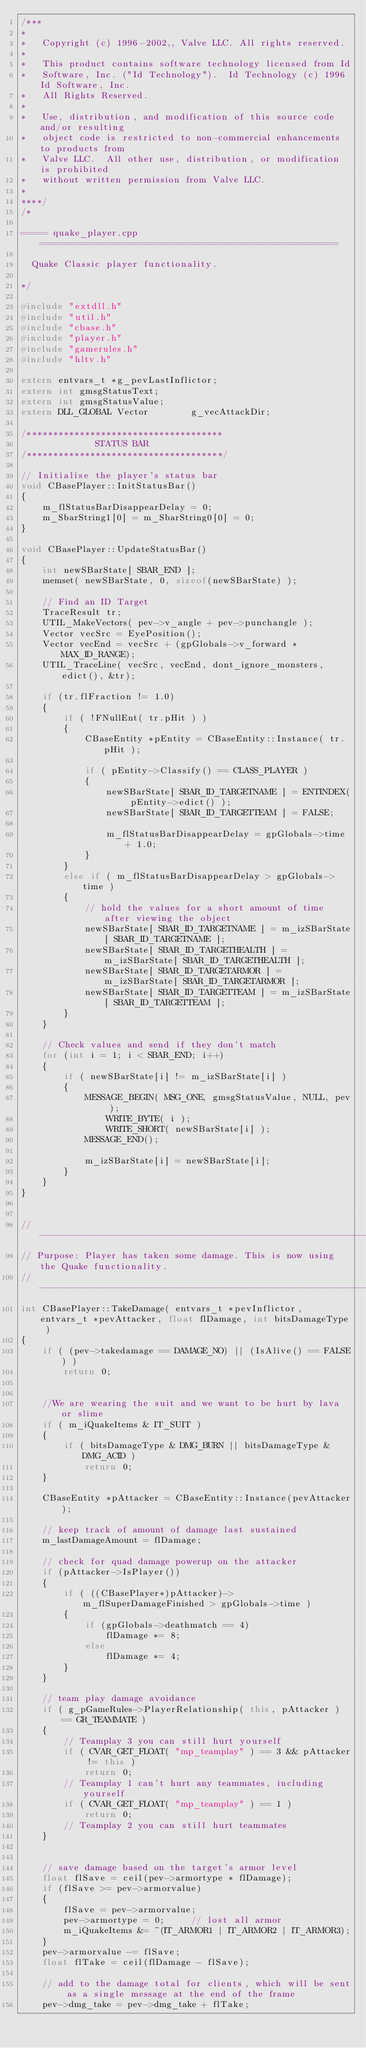Convert code to text. <code><loc_0><loc_0><loc_500><loc_500><_C++_>/***
*
*	Copyright (c) 1996-2002,, Valve LLC. All rights reserved.
*	
*	This product contains software technology licensed from Id 
*	Software, Inc. ("Id Technology").  Id Technology (c) 1996 Id Software, Inc. 
*	All Rights Reserved.
*
*   Use, distribution, and modification of this source code and/or resulting
*   object code is restricted to non-commercial enhancements to products from
*   Valve LLC.  All other use, distribution, or modification is prohibited
*   without written permission from Valve LLC.
*
****/
/*

===== quake_player.cpp ========================================================

  Quake Classic player functionality.

*/

#include "extdll.h"
#include "util.h"
#include "cbase.h"
#include "player.h"
#include "gamerules.h"
#include "hltv.h"

extern entvars_t *g_pevLastInflictor;
extern int gmsgStatusText;
extern int gmsgStatusValue; 
extern DLL_GLOBAL Vector		g_vecAttackDir;

/*************************************
			  STATUS BAR 
/*************************************/

// Initialise the player's status bar
void CBasePlayer::InitStatusBar()
{
	m_flStatusBarDisappearDelay = 0;
	m_SbarString1[0] = m_SbarString0[0] = 0; 
}

void CBasePlayer::UpdateStatusBar()
{
	int newSBarState[ SBAR_END ];
	memset( newSBarState, 0, sizeof(newSBarState) );

	// Find an ID Target
	TraceResult tr;
	UTIL_MakeVectors( pev->v_angle + pev->punchangle );
	Vector vecSrc = EyePosition();
	Vector vecEnd = vecSrc + (gpGlobals->v_forward * MAX_ID_RANGE);
	UTIL_TraceLine( vecSrc, vecEnd, dont_ignore_monsters, edict(), &tr);

	if (tr.flFraction != 1.0)
	{
		if ( !FNullEnt( tr.pHit ) )
		{
			CBaseEntity *pEntity = CBaseEntity::Instance( tr.pHit );

			if ( pEntity->Classify() == CLASS_PLAYER )
			{
				newSBarState[ SBAR_ID_TARGETNAME ] = ENTINDEX( pEntity->edict() );
				newSBarState[ SBAR_ID_TARGETTEAM ] = FALSE;
					
				m_flStatusBarDisappearDelay = gpGlobals->time + 1.0;
			}
		}
		else if ( m_flStatusBarDisappearDelay > gpGlobals->time )
		{
			// hold the values for a short amount of time after viewing the object
			newSBarState[ SBAR_ID_TARGETNAME ] = m_izSBarState[ SBAR_ID_TARGETNAME ];
			newSBarState[ SBAR_ID_TARGETHEALTH ] = m_izSBarState[ SBAR_ID_TARGETHEALTH ];
			newSBarState[ SBAR_ID_TARGETARMOR ] = m_izSBarState[ SBAR_ID_TARGETARMOR ];
			newSBarState[ SBAR_ID_TARGETTEAM ] = m_izSBarState[ SBAR_ID_TARGETTEAM ];
		}
	}

	// Check values and send if they don't match
	for (int i = 1; i < SBAR_END; i++)
	{
		if ( newSBarState[i] != m_izSBarState[i] )
		{
			MESSAGE_BEGIN( MSG_ONE, gmsgStatusValue, NULL, pev );
				WRITE_BYTE( i );
				WRITE_SHORT( newSBarState[i] );
			MESSAGE_END();

			m_izSBarState[i] = newSBarState[i];
		}
	}
}


//-----------------------------------------------------------------------------
// Purpose: Player has taken some damage. This is now using the Quake functionality.
//-----------------------------------------------------------------------------
int CBasePlayer::TakeDamage( entvars_t *pevInflictor, entvars_t *pevAttacker, float flDamage, int bitsDamageType )
{
	if ( (pev->takedamage == DAMAGE_NO) || (IsAlive() == FALSE) )
		return 0;


	//We are wearing the suit and we want to be hurt by lava or slime
	if ( m_iQuakeItems & IT_SUIT )
	{
		if ( bitsDamageType & DMG_BURN || bitsDamageType & DMG_ACID )
			return 0;
	}

	CBaseEntity *pAttacker = CBaseEntity::Instance(pevAttacker);

	// keep track of amount of damage last sustained
	m_lastDamageAmount = flDamage;

	// check for quad damage powerup on the attacker
	if (pAttacker->IsPlayer())
	{
		if ( ((CBasePlayer*)pAttacker)->m_flSuperDamageFinished > gpGlobals->time )
		{
			if (gpGlobals->deathmatch == 4)
				flDamage *= 8;
			else
				flDamage *= 4;
		}
	}

	// team play damage avoidance
	if ( g_pGameRules->PlayerRelationship( this, pAttacker ) == GR_TEAMMATE )
	{
		// Teamplay 3 you can still hurt yourself
		if ( CVAR_GET_FLOAT( "mp_teamplay" ) == 3 && pAttacker != this )
			return 0;
		// Teamplay 1 can't hurt any teammates, including yourself
		if ( CVAR_GET_FLOAT( "mp_teamplay" ) == 1 )
			return 0;
		// Teamplay 2 you can still hurt teammates
	}


	// save damage based on the target's armor level
	float flSave = ceil(pev->armortype * flDamage);
	if (flSave >= pev->armorvalue)
	{
		flSave = pev->armorvalue;
		pev->armortype = 0;     // lost all armor
		m_iQuakeItems &= ~(IT_ARMOR1 | IT_ARMOR2 | IT_ARMOR3);
	}
	pev->armorvalue -= flSave;
	float flTake = ceil(flDamage - flSave);

	// add to the damage total for clients, which will be sent as a single message at the end of the frame
	pev->dmg_take = pev->dmg_take + flTake;</code> 